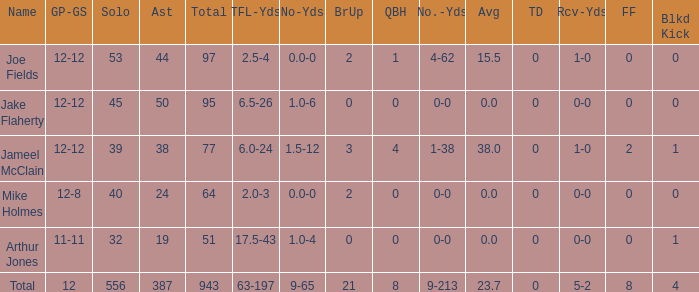How many players named jake flaherty? 1.0. 